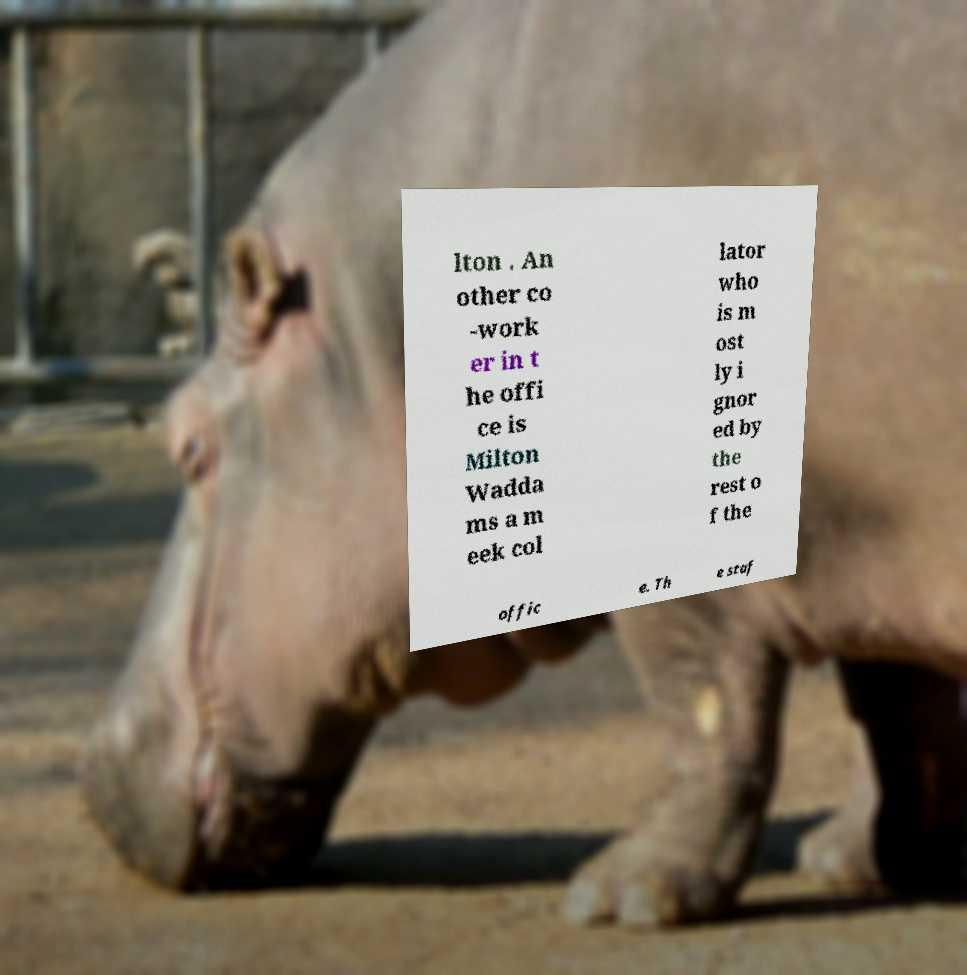Please identify and transcribe the text found in this image. lton . An other co -work er in t he offi ce is Milton Wadda ms a m eek col lator who is m ost ly i gnor ed by the rest o f the offic e. Th e staf 